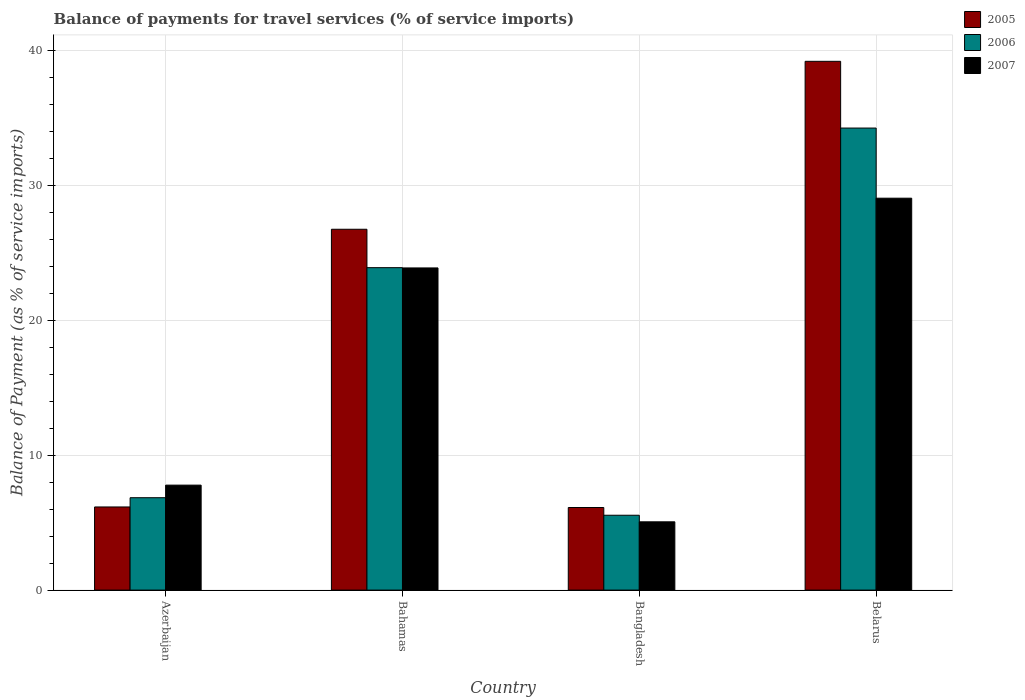How many groups of bars are there?
Give a very brief answer. 4. Are the number of bars per tick equal to the number of legend labels?
Give a very brief answer. Yes. How many bars are there on the 2nd tick from the left?
Make the answer very short. 3. What is the label of the 1st group of bars from the left?
Provide a succinct answer. Azerbaijan. In how many cases, is the number of bars for a given country not equal to the number of legend labels?
Ensure brevity in your answer.  0. What is the balance of payments for travel services in 2006 in Bahamas?
Your answer should be very brief. 23.92. Across all countries, what is the maximum balance of payments for travel services in 2005?
Give a very brief answer. 39.22. Across all countries, what is the minimum balance of payments for travel services in 2006?
Your answer should be very brief. 5.55. In which country was the balance of payments for travel services in 2005 maximum?
Provide a succinct answer. Belarus. In which country was the balance of payments for travel services in 2006 minimum?
Provide a succinct answer. Bangladesh. What is the total balance of payments for travel services in 2005 in the graph?
Offer a very short reply. 78.28. What is the difference between the balance of payments for travel services in 2007 in Azerbaijan and that in Bahamas?
Provide a short and direct response. -16.11. What is the difference between the balance of payments for travel services in 2006 in Bahamas and the balance of payments for travel services in 2007 in Belarus?
Provide a short and direct response. -5.15. What is the average balance of payments for travel services in 2005 per country?
Offer a terse response. 19.57. What is the difference between the balance of payments for travel services of/in 2005 and balance of payments for travel services of/in 2006 in Bangladesh?
Give a very brief answer. 0.57. What is the ratio of the balance of payments for travel services in 2007 in Azerbaijan to that in Belarus?
Provide a short and direct response. 0.27. Is the balance of payments for travel services in 2006 in Bahamas less than that in Belarus?
Offer a terse response. Yes. What is the difference between the highest and the second highest balance of payments for travel services in 2006?
Give a very brief answer. 27.42. What is the difference between the highest and the lowest balance of payments for travel services in 2006?
Keep it short and to the point. 28.72. In how many countries, is the balance of payments for travel services in 2006 greater than the average balance of payments for travel services in 2006 taken over all countries?
Your answer should be very brief. 2. Is the sum of the balance of payments for travel services in 2006 in Bahamas and Bangladesh greater than the maximum balance of payments for travel services in 2005 across all countries?
Give a very brief answer. No. What does the 2nd bar from the left in Azerbaijan represents?
Keep it short and to the point. 2006. What does the 3rd bar from the right in Belarus represents?
Your answer should be compact. 2005. Does the graph contain grids?
Keep it short and to the point. Yes. Where does the legend appear in the graph?
Ensure brevity in your answer.  Top right. How many legend labels are there?
Keep it short and to the point. 3. How are the legend labels stacked?
Offer a very short reply. Vertical. What is the title of the graph?
Make the answer very short. Balance of payments for travel services (% of service imports). What is the label or title of the X-axis?
Your response must be concise. Country. What is the label or title of the Y-axis?
Provide a short and direct response. Balance of Payment (as % of service imports). What is the Balance of Payment (as % of service imports) in 2005 in Azerbaijan?
Offer a very short reply. 6.17. What is the Balance of Payment (as % of service imports) in 2006 in Azerbaijan?
Make the answer very short. 6.85. What is the Balance of Payment (as % of service imports) in 2007 in Azerbaijan?
Your answer should be very brief. 7.79. What is the Balance of Payment (as % of service imports) of 2005 in Bahamas?
Provide a short and direct response. 26.76. What is the Balance of Payment (as % of service imports) in 2006 in Bahamas?
Ensure brevity in your answer.  23.92. What is the Balance of Payment (as % of service imports) of 2007 in Bahamas?
Offer a terse response. 23.89. What is the Balance of Payment (as % of service imports) in 2005 in Bangladesh?
Make the answer very short. 6.13. What is the Balance of Payment (as % of service imports) in 2006 in Bangladesh?
Give a very brief answer. 5.55. What is the Balance of Payment (as % of service imports) of 2007 in Bangladesh?
Provide a succinct answer. 5.06. What is the Balance of Payment (as % of service imports) of 2005 in Belarus?
Keep it short and to the point. 39.22. What is the Balance of Payment (as % of service imports) of 2006 in Belarus?
Provide a short and direct response. 34.27. What is the Balance of Payment (as % of service imports) in 2007 in Belarus?
Your answer should be very brief. 29.07. Across all countries, what is the maximum Balance of Payment (as % of service imports) of 2005?
Offer a terse response. 39.22. Across all countries, what is the maximum Balance of Payment (as % of service imports) in 2006?
Offer a terse response. 34.27. Across all countries, what is the maximum Balance of Payment (as % of service imports) in 2007?
Your response must be concise. 29.07. Across all countries, what is the minimum Balance of Payment (as % of service imports) of 2005?
Provide a short and direct response. 6.13. Across all countries, what is the minimum Balance of Payment (as % of service imports) of 2006?
Your answer should be very brief. 5.55. Across all countries, what is the minimum Balance of Payment (as % of service imports) of 2007?
Offer a very short reply. 5.06. What is the total Balance of Payment (as % of service imports) in 2005 in the graph?
Provide a short and direct response. 78.28. What is the total Balance of Payment (as % of service imports) of 2006 in the graph?
Provide a short and direct response. 70.59. What is the total Balance of Payment (as % of service imports) of 2007 in the graph?
Your answer should be compact. 65.81. What is the difference between the Balance of Payment (as % of service imports) in 2005 in Azerbaijan and that in Bahamas?
Your answer should be very brief. -20.6. What is the difference between the Balance of Payment (as % of service imports) in 2006 in Azerbaijan and that in Bahamas?
Ensure brevity in your answer.  -17.06. What is the difference between the Balance of Payment (as % of service imports) in 2007 in Azerbaijan and that in Bahamas?
Provide a succinct answer. -16.11. What is the difference between the Balance of Payment (as % of service imports) in 2005 in Azerbaijan and that in Bangladesh?
Provide a succinct answer. 0.04. What is the difference between the Balance of Payment (as % of service imports) in 2006 in Azerbaijan and that in Bangladesh?
Offer a very short reply. 1.3. What is the difference between the Balance of Payment (as % of service imports) of 2007 in Azerbaijan and that in Bangladesh?
Give a very brief answer. 2.72. What is the difference between the Balance of Payment (as % of service imports) in 2005 in Azerbaijan and that in Belarus?
Make the answer very short. -33.05. What is the difference between the Balance of Payment (as % of service imports) in 2006 in Azerbaijan and that in Belarus?
Give a very brief answer. -27.42. What is the difference between the Balance of Payment (as % of service imports) of 2007 in Azerbaijan and that in Belarus?
Your answer should be very brief. -21.28. What is the difference between the Balance of Payment (as % of service imports) of 2005 in Bahamas and that in Bangladesh?
Keep it short and to the point. 20.64. What is the difference between the Balance of Payment (as % of service imports) of 2006 in Bahamas and that in Bangladesh?
Keep it short and to the point. 18.36. What is the difference between the Balance of Payment (as % of service imports) in 2007 in Bahamas and that in Bangladesh?
Your answer should be very brief. 18.83. What is the difference between the Balance of Payment (as % of service imports) of 2005 in Bahamas and that in Belarus?
Keep it short and to the point. -12.46. What is the difference between the Balance of Payment (as % of service imports) of 2006 in Bahamas and that in Belarus?
Offer a terse response. -10.36. What is the difference between the Balance of Payment (as % of service imports) in 2007 in Bahamas and that in Belarus?
Make the answer very short. -5.17. What is the difference between the Balance of Payment (as % of service imports) of 2005 in Bangladesh and that in Belarus?
Your response must be concise. -33.09. What is the difference between the Balance of Payment (as % of service imports) of 2006 in Bangladesh and that in Belarus?
Provide a succinct answer. -28.72. What is the difference between the Balance of Payment (as % of service imports) of 2007 in Bangladesh and that in Belarus?
Your answer should be compact. -24. What is the difference between the Balance of Payment (as % of service imports) in 2005 in Azerbaijan and the Balance of Payment (as % of service imports) in 2006 in Bahamas?
Make the answer very short. -17.75. What is the difference between the Balance of Payment (as % of service imports) of 2005 in Azerbaijan and the Balance of Payment (as % of service imports) of 2007 in Bahamas?
Your response must be concise. -17.73. What is the difference between the Balance of Payment (as % of service imports) of 2006 in Azerbaijan and the Balance of Payment (as % of service imports) of 2007 in Bahamas?
Provide a short and direct response. -17.04. What is the difference between the Balance of Payment (as % of service imports) in 2005 in Azerbaijan and the Balance of Payment (as % of service imports) in 2006 in Bangladesh?
Keep it short and to the point. 0.61. What is the difference between the Balance of Payment (as % of service imports) of 2005 in Azerbaijan and the Balance of Payment (as % of service imports) of 2007 in Bangladesh?
Keep it short and to the point. 1.1. What is the difference between the Balance of Payment (as % of service imports) of 2006 in Azerbaijan and the Balance of Payment (as % of service imports) of 2007 in Bangladesh?
Your response must be concise. 1.79. What is the difference between the Balance of Payment (as % of service imports) of 2005 in Azerbaijan and the Balance of Payment (as % of service imports) of 2006 in Belarus?
Your answer should be compact. -28.1. What is the difference between the Balance of Payment (as % of service imports) in 2005 in Azerbaijan and the Balance of Payment (as % of service imports) in 2007 in Belarus?
Make the answer very short. -22.9. What is the difference between the Balance of Payment (as % of service imports) of 2006 in Azerbaijan and the Balance of Payment (as % of service imports) of 2007 in Belarus?
Make the answer very short. -22.22. What is the difference between the Balance of Payment (as % of service imports) in 2005 in Bahamas and the Balance of Payment (as % of service imports) in 2006 in Bangladesh?
Offer a terse response. 21.21. What is the difference between the Balance of Payment (as % of service imports) in 2005 in Bahamas and the Balance of Payment (as % of service imports) in 2007 in Bangladesh?
Offer a very short reply. 21.7. What is the difference between the Balance of Payment (as % of service imports) of 2006 in Bahamas and the Balance of Payment (as % of service imports) of 2007 in Bangladesh?
Your response must be concise. 18.85. What is the difference between the Balance of Payment (as % of service imports) of 2005 in Bahamas and the Balance of Payment (as % of service imports) of 2006 in Belarus?
Your answer should be very brief. -7.51. What is the difference between the Balance of Payment (as % of service imports) of 2005 in Bahamas and the Balance of Payment (as % of service imports) of 2007 in Belarus?
Ensure brevity in your answer.  -2.3. What is the difference between the Balance of Payment (as % of service imports) of 2006 in Bahamas and the Balance of Payment (as % of service imports) of 2007 in Belarus?
Your answer should be very brief. -5.15. What is the difference between the Balance of Payment (as % of service imports) in 2005 in Bangladesh and the Balance of Payment (as % of service imports) in 2006 in Belarus?
Your response must be concise. -28.14. What is the difference between the Balance of Payment (as % of service imports) of 2005 in Bangladesh and the Balance of Payment (as % of service imports) of 2007 in Belarus?
Provide a short and direct response. -22.94. What is the difference between the Balance of Payment (as % of service imports) of 2006 in Bangladesh and the Balance of Payment (as % of service imports) of 2007 in Belarus?
Your answer should be compact. -23.52. What is the average Balance of Payment (as % of service imports) of 2005 per country?
Your answer should be compact. 19.57. What is the average Balance of Payment (as % of service imports) in 2006 per country?
Your answer should be compact. 17.65. What is the average Balance of Payment (as % of service imports) of 2007 per country?
Ensure brevity in your answer.  16.45. What is the difference between the Balance of Payment (as % of service imports) of 2005 and Balance of Payment (as % of service imports) of 2006 in Azerbaijan?
Keep it short and to the point. -0.69. What is the difference between the Balance of Payment (as % of service imports) in 2005 and Balance of Payment (as % of service imports) in 2007 in Azerbaijan?
Your response must be concise. -1.62. What is the difference between the Balance of Payment (as % of service imports) of 2006 and Balance of Payment (as % of service imports) of 2007 in Azerbaijan?
Offer a very short reply. -0.93. What is the difference between the Balance of Payment (as % of service imports) in 2005 and Balance of Payment (as % of service imports) in 2006 in Bahamas?
Offer a terse response. 2.85. What is the difference between the Balance of Payment (as % of service imports) in 2005 and Balance of Payment (as % of service imports) in 2007 in Bahamas?
Offer a terse response. 2.87. What is the difference between the Balance of Payment (as % of service imports) of 2006 and Balance of Payment (as % of service imports) of 2007 in Bahamas?
Keep it short and to the point. 0.02. What is the difference between the Balance of Payment (as % of service imports) of 2005 and Balance of Payment (as % of service imports) of 2006 in Bangladesh?
Offer a terse response. 0.57. What is the difference between the Balance of Payment (as % of service imports) of 2005 and Balance of Payment (as % of service imports) of 2007 in Bangladesh?
Offer a terse response. 1.06. What is the difference between the Balance of Payment (as % of service imports) in 2006 and Balance of Payment (as % of service imports) in 2007 in Bangladesh?
Offer a very short reply. 0.49. What is the difference between the Balance of Payment (as % of service imports) in 2005 and Balance of Payment (as % of service imports) in 2006 in Belarus?
Give a very brief answer. 4.95. What is the difference between the Balance of Payment (as % of service imports) of 2005 and Balance of Payment (as % of service imports) of 2007 in Belarus?
Your response must be concise. 10.15. What is the difference between the Balance of Payment (as % of service imports) of 2006 and Balance of Payment (as % of service imports) of 2007 in Belarus?
Keep it short and to the point. 5.2. What is the ratio of the Balance of Payment (as % of service imports) of 2005 in Azerbaijan to that in Bahamas?
Provide a succinct answer. 0.23. What is the ratio of the Balance of Payment (as % of service imports) in 2006 in Azerbaijan to that in Bahamas?
Your answer should be compact. 0.29. What is the ratio of the Balance of Payment (as % of service imports) in 2007 in Azerbaijan to that in Bahamas?
Offer a terse response. 0.33. What is the ratio of the Balance of Payment (as % of service imports) in 2006 in Azerbaijan to that in Bangladesh?
Provide a succinct answer. 1.23. What is the ratio of the Balance of Payment (as % of service imports) of 2007 in Azerbaijan to that in Bangladesh?
Your answer should be very brief. 1.54. What is the ratio of the Balance of Payment (as % of service imports) of 2005 in Azerbaijan to that in Belarus?
Offer a very short reply. 0.16. What is the ratio of the Balance of Payment (as % of service imports) in 2006 in Azerbaijan to that in Belarus?
Ensure brevity in your answer.  0.2. What is the ratio of the Balance of Payment (as % of service imports) of 2007 in Azerbaijan to that in Belarus?
Offer a terse response. 0.27. What is the ratio of the Balance of Payment (as % of service imports) in 2005 in Bahamas to that in Bangladesh?
Provide a short and direct response. 4.37. What is the ratio of the Balance of Payment (as % of service imports) of 2006 in Bahamas to that in Bangladesh?
Keep it short and to the point. 4.31. What is the ratio of the Balance of Payment (as % of service imports) in 2007 in Bahamas to that in Bangladesh?
Your answer should be compact. 4.72. What is the ratio of the Balance of Payment (as % of service imports) of 2005 in Bahamas to that in Belarus?
Your answer should be very brief. 0.68. What is the ratio of the Balance of Payment (as % of service imports) in 2006 in Bahamas to that in Belarus?
Ensure brevity in your answer.  0.7. What is the ratio of the Balance of Payment (as % of service imports) in 2007 in Bahamas to that in Belarus?
Offer a terse response. 0.82. What is the ratio of the Balance of Payment (as % of service imports) of 2005 in Bangladesh to that in Belarus?
Offer a very short reply. 0.16. What is the ratio of the Balance of Payment (as % of service imports) in 2006 in Bangladesh to that in Belarus?
Give a very brief answer. 0.16. What is the ratio of the Balance of Payment (as % of service imports) of 2007 in Bangladesh to that in Belarus?
Your answer should be compact. 0.17. What is the difference between the highest and the second highest Balance of Payment (as % of service imports) of 2005?
Provide a short and direct response. 12.46. What is the difference between the highest and the second highest Balance of Payment (as % of service imports) in 2006?
Your answer should be very brief. 10.36. What is the difference between the highest and the second highest Balance of Payment (as % of service imports) of 2007?
Ensure brevity in your answer.  5.17. What is the difference between the highest and the lowest Balance of Payment (as % of service imports) in 2005?
Your answer should be compact. 33.09. What is the difference between the highest and the lowest Balance of Payment (as % of service imports) of 2006?
Your response must be concise. 28.72. What is the difference between the highest and the lowest Balance of Payment (as % of service imports) of 2007?
Give a very brief answer. 24. 